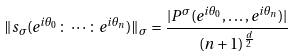Convert formula to latex. <formula><loc_0><loc_0><loc_500><loc_500>\| s _ { \sigma } ( e ^ { i \theta _ { 0 } } \colon \cdots \colon e ^ { i \theta _ { n } } ) \| _ { \sigma } = \frac { | P ^ { \sigma } ( e ^ { i \theta _ { 0 } } , \dots , e ^ { i \theta _ { n } } ) | } { ( n + 1 ) ^ { \frac { d } { 2 } } }</formula> 